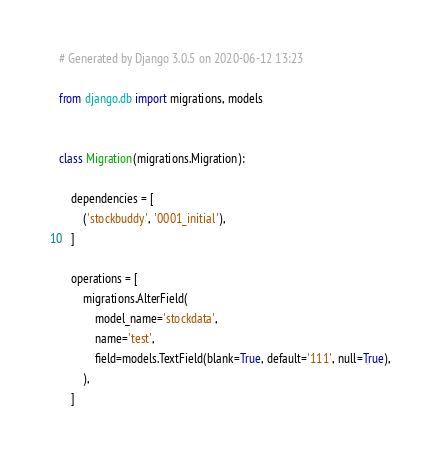Convert code to text. <code><loc_0><loc_0><loc_500><loc_500><_Python_># Generated by Django 3.0.5 on 2020-06-12 13:23

from django.db import migrations, models


class Migration(migrations.Migration):

    dependencies = [
        ('stockbuddy', '0001_initial'),
    ]

    operations = [
        migrations.AlterField(
            model_name='stockdata',
            name='test',
            field=models.TextField(blank=True, default='111', null=True),
        ),
    ]
</code> 